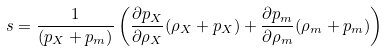Convert formula to latex. <formula><loc_0><loc_0><loc_500><loc_500>s = \frac { 1 } { ( p _ { X } + p _ { m } ) } \left ( \frac { \partial p _ { X } } { \partial \rho _ { X } } ( \rho _ { X } + p _ { X } ) + \frac { \partial p _ { m } } { \partial \rho _ { m } } ( \rho _ { m } + p _ { m } ) \right )</formula> 